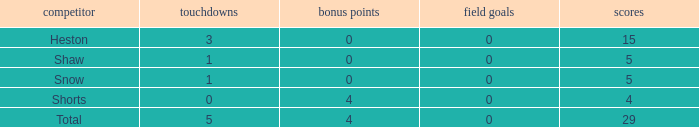What is the sum of all the touchdowns when the player had more than 0 extra points and less than 0 field goals? None. Would you be able to parse every entry in this table? {'header': ['competitor', 'touchdowns', 'bonus points', 'field goals', 'scores'], 'rows': [['Heston', '3', '0', '0', '15'], ['Shaw', '1', '0', '0', '5'], ['Snow', '1', '0', '0', '5'], ['Shorts', '0', '4', '0', '4'], ['Total', '5', '4', '0', '29']]} 